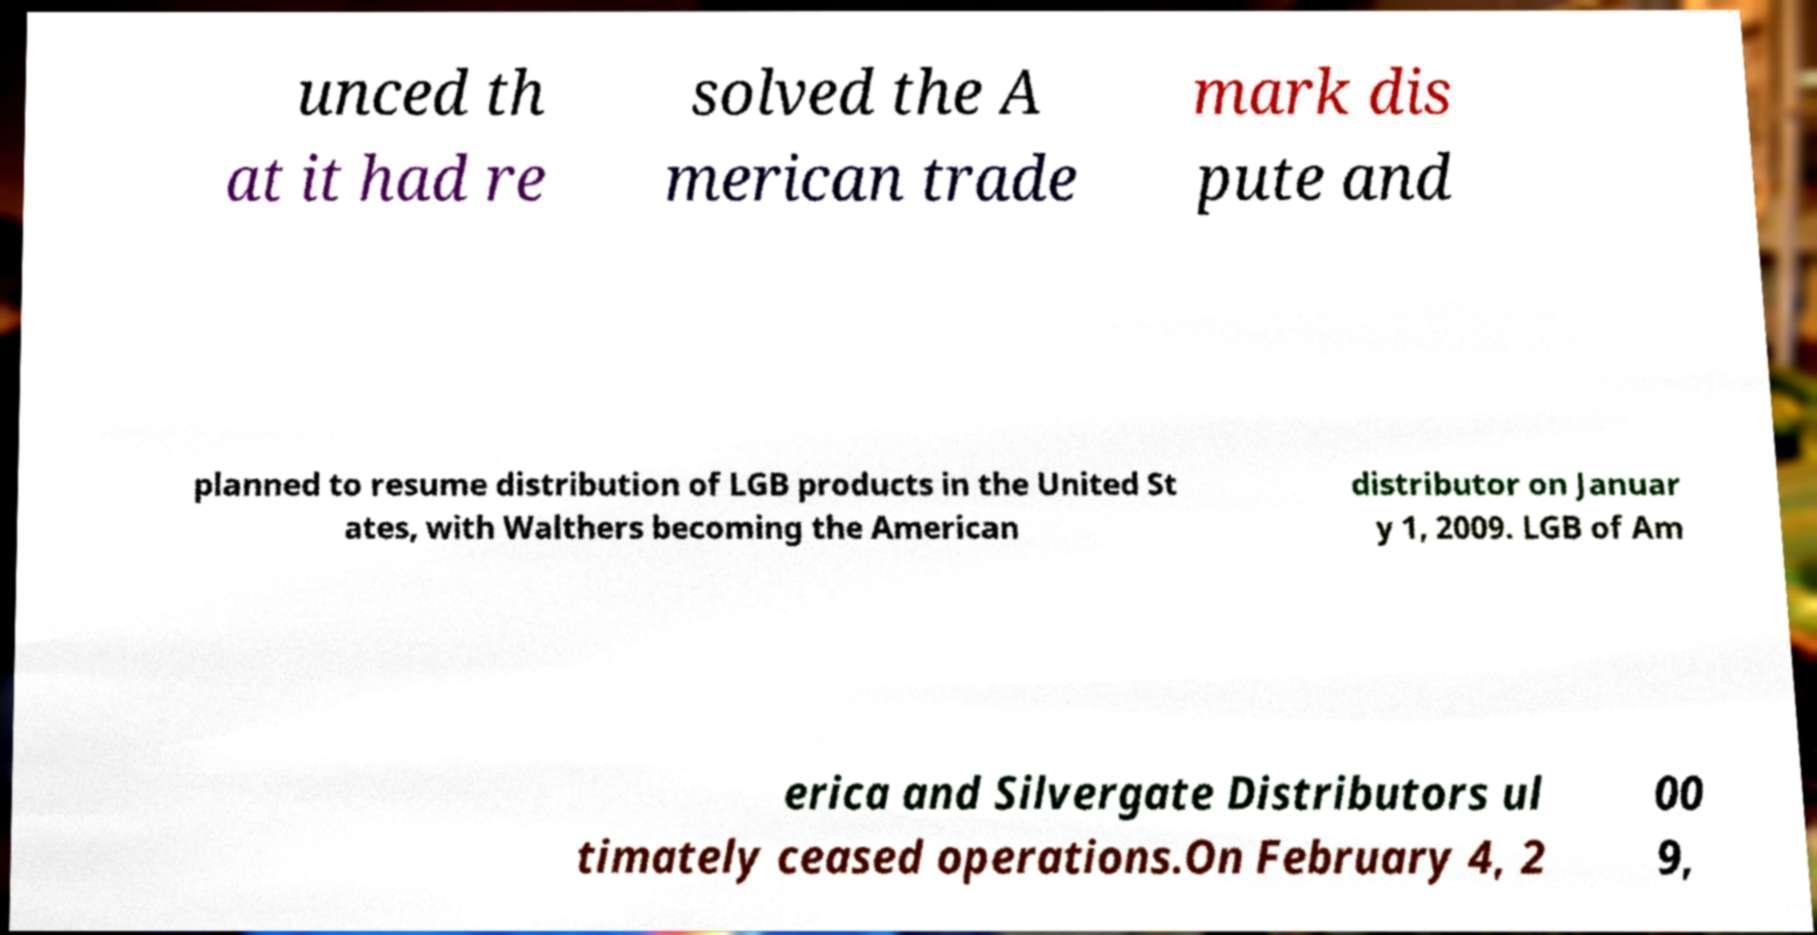Can you accurately transcribe the text from the provided image for me? unced th at it had re solved the A merican trade mark dis pute and planned to resume distribution of LGB products in the United St ates, with Walthers becoming the American distributor on Januar y 1, 2009. LGB of Am erica and Silvergate Distributors ul timately ceased operations.On February 4, 2 00 9, 